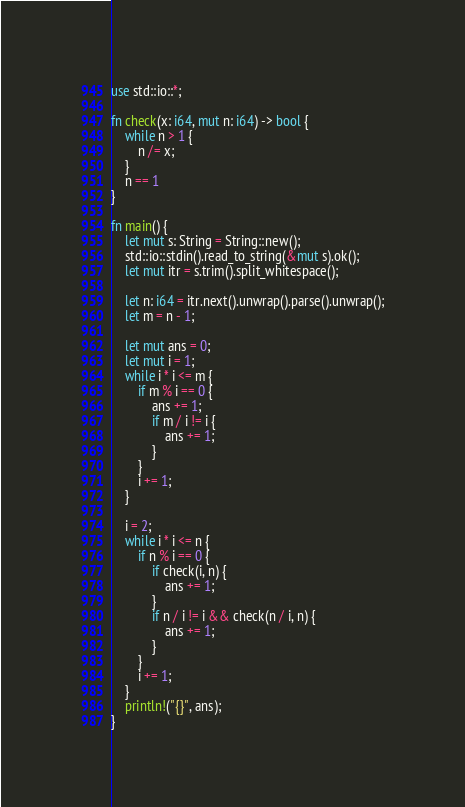Convert code to text. <code><loc_0><loc_0><loc_500><loc_500><_Rust_>use std::io::*;

fn check(x: i64, mut n: i64) -> bool {
    while n > 1 {
        n /= x;
    }
    n == 1
}

fn main() {
    let mut s: String = String::new();
    std::io::stdin().read_to_string(&mut s).ok();
    let mut itr = s.trim().split_whitespace();

    let n: i64 = itr.next().unwrap().parse().unwrap();
    let m = n - 1;

    let mut ans = 0;
    let mut i = 1;
    while i * i <= m {
        if m % i == 0 {
            ans += 1;
            if m / i != i {
                ans += 1;
            }
        }
        i += 1;
    }

    i = 2;
    while i * i <= n {
        if n % i == 0 {
            if check(i, n) {
                ans += 1;
            }
            if n / i != i && check(n / i, n) {
                ans += 1;
            }
        }
        i += 1;
    }
    println!("{}", ans);
}
</code> 